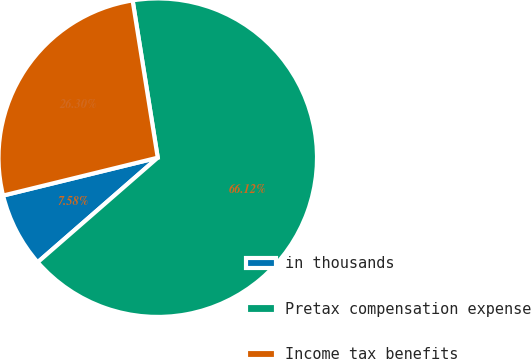Convert chart to OTSL. <chart><loc_0><loc_0><loc_500><loc_500><pie_chart><fcel>in thousands<fcel>Pretax compensation expense<fcel>Income tax benefits<nl><fcel>7.58%<fcel>66.12%<fcel>26.3%<nl></chart> 